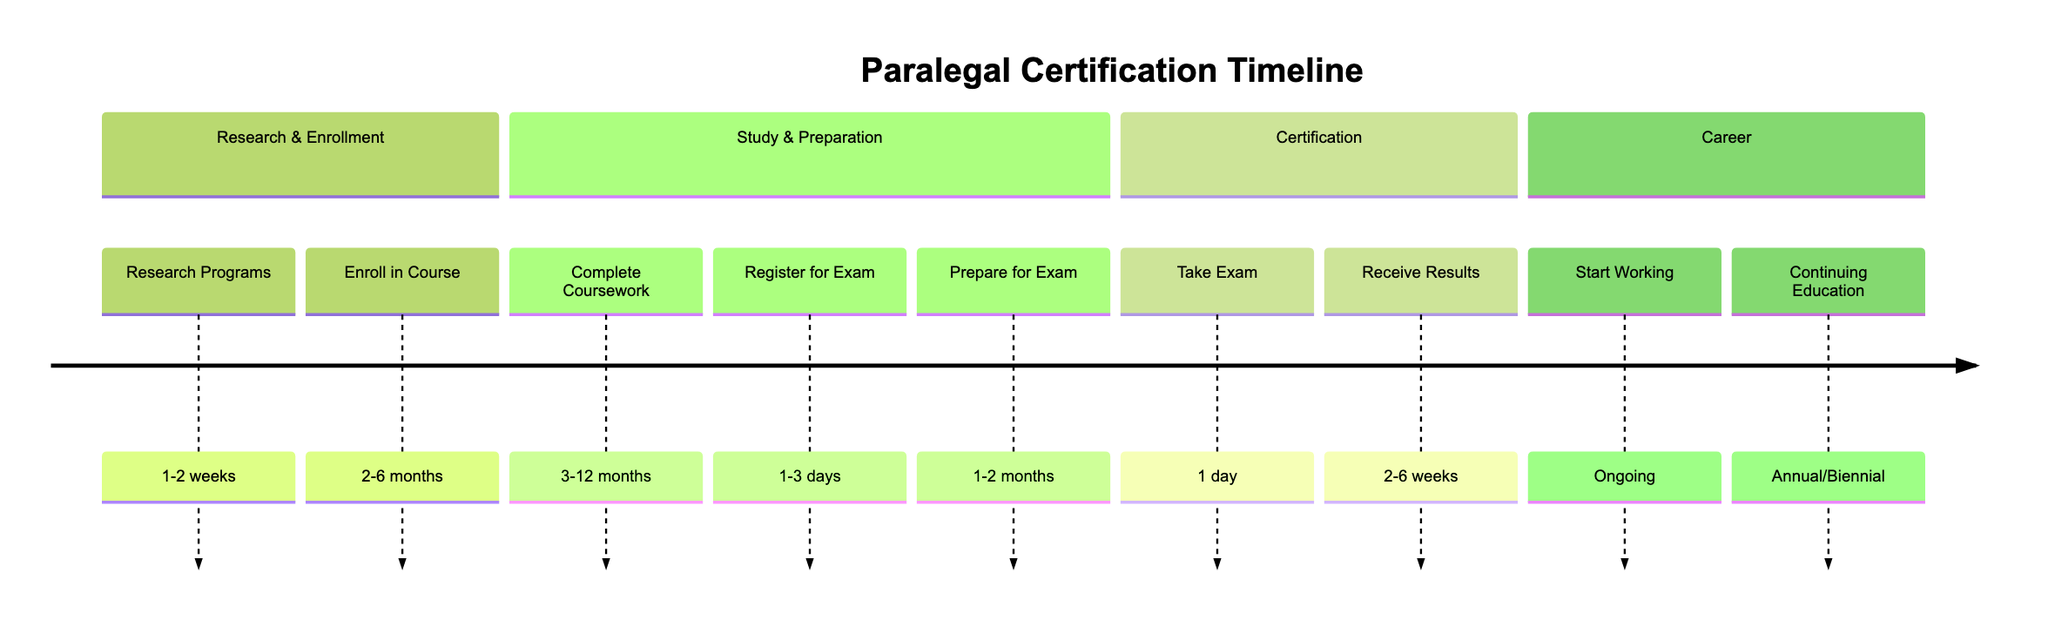What is the first step in the paralegal certification process? The first step listed in the timeline is "Research Paralegal Certification Programs." This is found in the "Research & Enrollment" section and is the initial action required before entering a program.
Answer: Research Paralegal Certification Programs How long does it take to complete the coursework? According to the timeline, "Complete Coursework" has a duration ranging from 3 to 12 months. This is specified in the "Study & Preparation" section of the timeline.
Answer: 3-12 months What is the duration for preparing for the exam? The timeline states that the duration for "Prepare for Exam" is between 1 and 2 months. This step is crucial for ensuring readiness before taking the certification exam and is found in the "Study & Preparation" section.
Answer: 1-2 months How long do results take to be received after taking the exam? The "Receive Results" step indicates a waiting period of 2 to 6 weeks after taking the exam. This step is part of the "Certification" section of the timeline.
Answer: 2-6 weeks What is the last step listed in the timeline? The last step mentioned is "Engage in Continuing Education," which is noted to be ongoing and part of the "Career" section. This indicates the need for ongoing professional development after certification.
Answer: Engage in Continuing Education Which steps are involved in enrollment? The enrollment process includes "Research Programs" and "Enroll in Course." These two steps are in the "Research & Enrollment" section and are prerequisite actions before study and preparation.
Answer: Research Programs, Enroll in Course How much time is designated to take the certification exam? The timeline specifies that taking the exam itself lasts "1 day." This is found in the "Certification" section, highlighting the actual day of testing.
Answer: 1 day What is the main goal after receiving certification? The timeline states that the goal is to "Start Working as a Certified Paralegal," which marks the transition into a professional role within the legal field. This is in the "Career" section, emphasizing the applicability of certification.
Answer: Start Working as a Certified Paralegal What is the interval for continuing education? The timeline indicates that continuing education occurs on an "Annual or Biennial" basis, highlighting the need for ongoing learning and certification maintenance. This information is in the "Career" section.
Answer: Annual or Biennial 